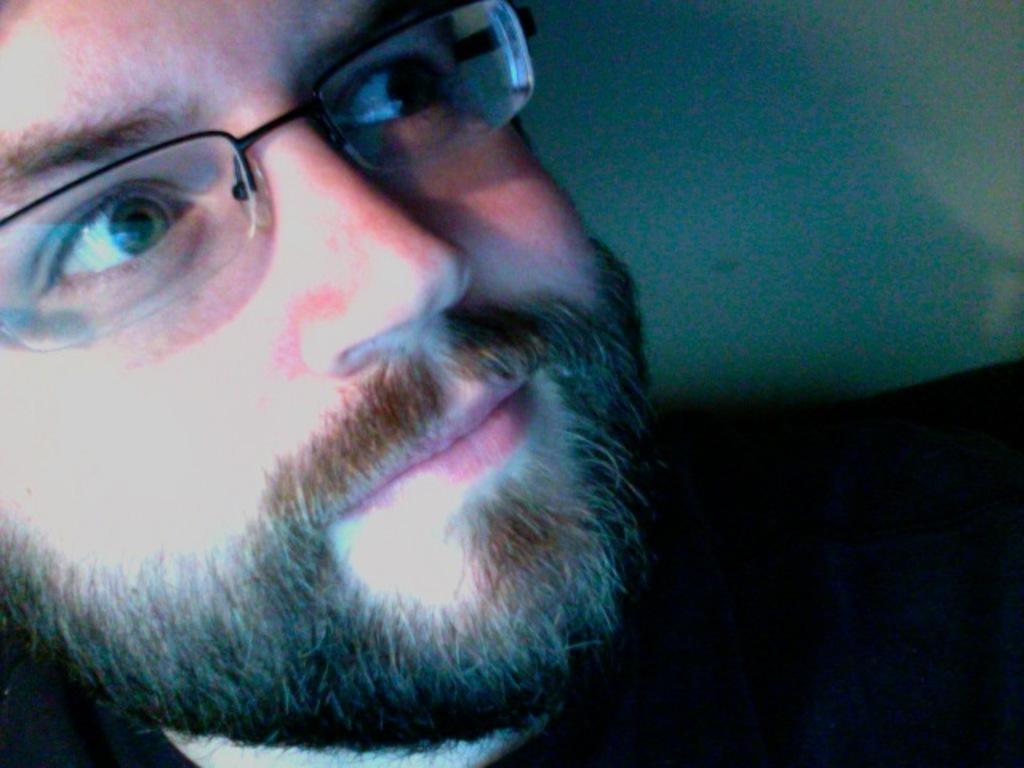In one or two sentences, can you explain what this image depicts? In this image we can see a person wearing specs. 